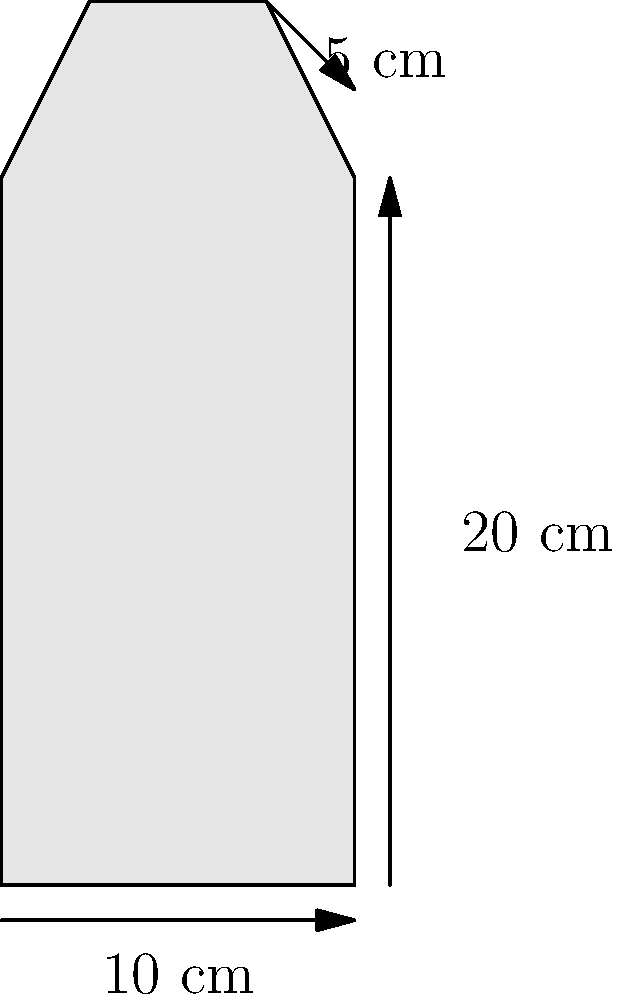A traditional cooking pot has a cylindrical shape with a slightly tapered top. The base diameter is 10 cm, the height is 20 cm, and the top diameter is 5 cm less than the base. Calculate the volume of this pot in liters, assuming it's a truncated cone. Round your answer to two decimal places. To calculate the volume of this truncated cone-shaped pot, we'll use the formula:

$$V = \frac{1}{3}\pi h(R^2 + r^2 + Rr)$$

Where:
$V$ = volume
$h$ = height
$R$ = radius of the base
$r$ = radius of the top

Step 1: Determine the radii
Base radius: $R = 10 \text{ cm} \div 2 = 5 \text{ cm}$
Top radius: $r = (10 - 5) \text{ cm} \div 2 = 2.5 \text{ cm}$

Step 2: Apply the formula
$$V = \frac{1}{3}\pi \cdot 20 \text{ cm} \cdot (5^2 + 2.5^2 + 5 \cdot 2.5) \text{ cm}^2$$

Step 3: Calculate
$$V = \frac{1}{3}\pi \cdot 20 \cdot (25 + 6.25 + 12.5) \text{ cm}^3$$
$$V = \frac{1}{3}\pi \cdot 20 \cdot 43.75 \text{ cm}^3$$
$$V = 916.3 \text{ cm}^3$$

Step 4: Convert to liters
$916.3 \text{ cm}^3 = 0.9163 \text{ L}$

Step 5: Round to two decimal places
$0.92 \text{ L}$
Answer: 0.92 L 